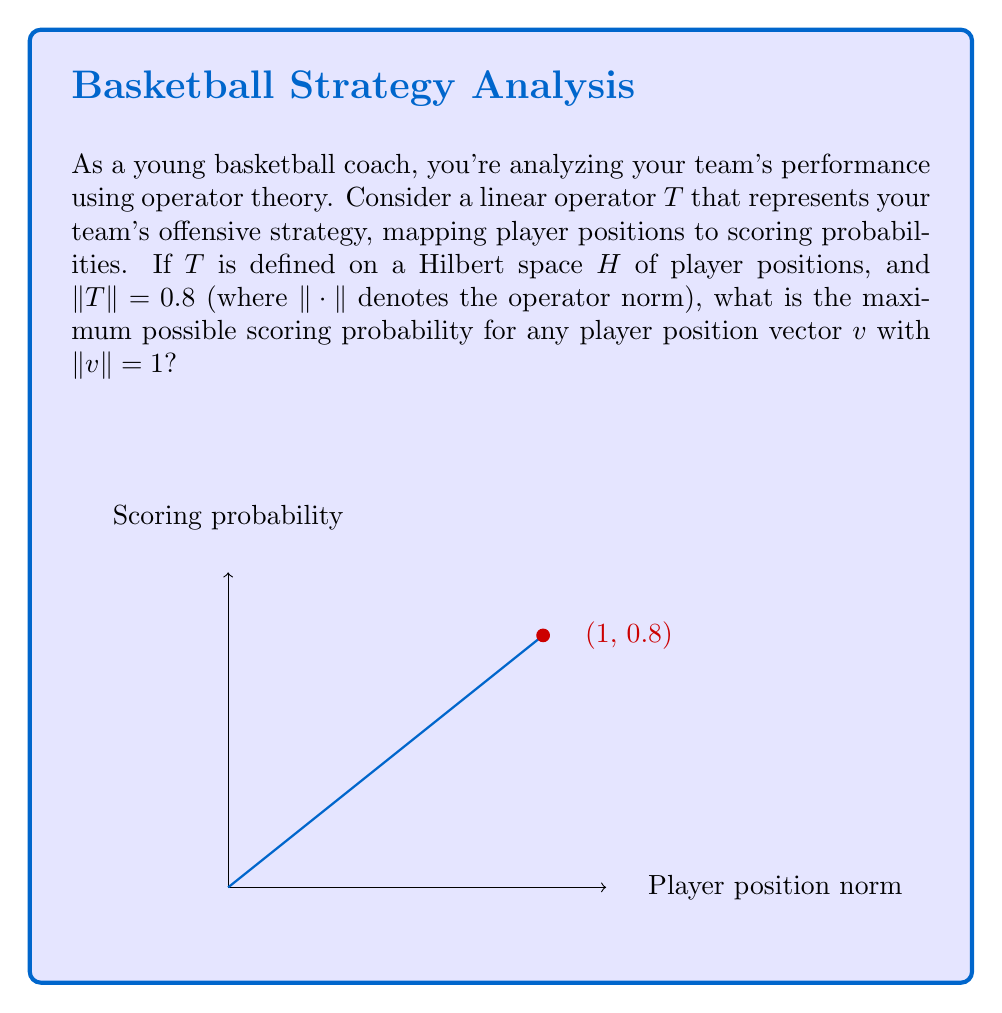What is the answer to this math problem? Let's approach this step-by-step:

1) The operator norm $\|T\|$ is defined as:

   $$\|T\| = \sup_{v \neq 0} \frac{\|Tv\|}{\|v\|} = \sup_{\|v\|=1} \|Tv\|$$

2) We're given that $\|T\| = 0.8$ and we're looking for the maximum scoring probability for any player position vector $v$ with $\|v\| = 1$.

3) The scoring probability for a player position vector $v$ is represented by $\|Tv\|$.

4) From the definition of the operator norm, we know that for any vector $v$:

   $$\|Tv\| \leq \|T\| \cdot \|v\|$$

5) In this case, we're considering vectors $v$ with $\|v\| = 1$, so:

   $$\|Tv\| \leq \|T\| \cdot 1 = 0.8$$

6) The equality in step 5 is achieved for some vector(s) $v$ with $\|v\| = 1$, otherwise the supremum in the definition of the operator norm would be less than 0.8.

7) Therefore, the maximum possible scoring probability is exactly 0.8.

This result implies that no matter how you position your players (represented by a unit vector in the Hilbert space), the maximum scoring probability you can achieve under this offensive strategy is 0.8 or 80%.
Answer: 0.8 